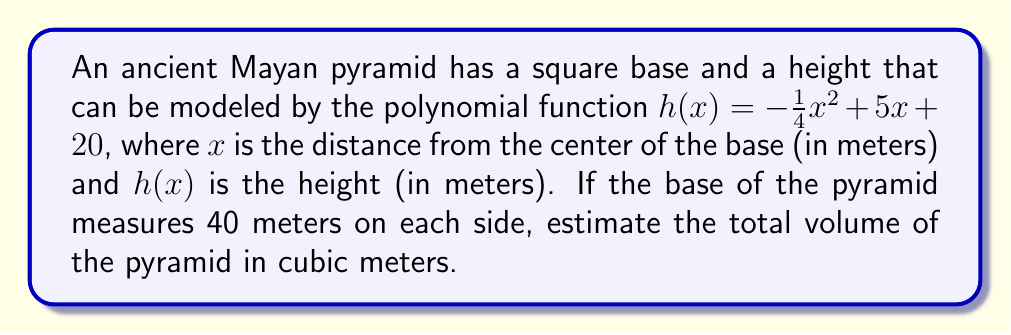Help me with this question. To solve this problem, we'll follow these steps:

1) First, we need to find the height of the pyramid at its peak. The peak occurs at the center of the base, where $x = 0$:

   $h(0) = -\frac{1}{4}(0)^2 + 5(0) + 20 = 20$ meters

2) Now, we need to find the volume of the pyramid. The formula for the volume of a pyramid is:

   $V = \frac{1}{3} * B * h$

   where $B$ is the area of the base and $h$ is the height.

3) We know the base is a square with side length 40 meters, so:

   $B = 40^2 = 1600$ square meters

4) Substituting into the volume formula:

   $V = \frac{1}{3} * 1600 * 20 = 10,666.67$ cubic meters

5) However, this is an overestimate because our height function is not linear. To get a more accurate estimate, we can use integral calculus to find the volume:

   $V = \int_{-20}^{20} \int_{-20}^{20} h(x) dy dx$

6) Substituting our height function:

   $V = \int_{-20}^{20} \int_{-20}^{20} (-\frac{1}{4}x^2 + 5x + 20) dy dx$

7) Solving this double integral:

   $V = \int_{-20}^{20} [(-\frac{1}{4}x^2 + 5x + 20)y]_{-20}^{20} dx$
   
   $V = \int_{-20}^{20} 40(-\frac{1}{4}x^2 + 5x + 20) dx$
   
   $V = 40[-\frac{1}{12}x^3 + \frac{5}{2}x^2 + 20x]_{-20}^{20}$
   
   $V = 40[(-\frac{1}{12}(8000) + \frac{5}{2}(400) + 20(20)) - (-\frac{1}{12}(-8000) + \frac{5}{2}(400) + 20(-20))]$
   
   $V = 40[-666.67 + 1000 + 400 - (666.67 + 1000 - 400)]$
   
   $V = 40[733.33 - 1266.67] = 40[-533.34] = -21,333.6$

8) The negative sign is due to our coordinate system. Taking the absolute value:

   $V \approx 21,333.6$ cubic meters
Answer: 21,333.6 cubic meters 